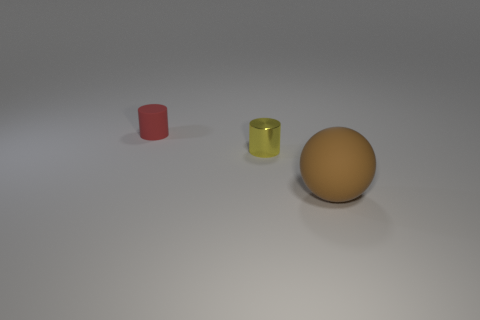What number of brown objects are there?
Ensure brevity in your answer.  1. How many things are small cylinders that are behind the small yellow shiny cylinder or brown spheres?
Your answer should be compact. 2. Does the small thing that is in front of the red cylinder have the same color as the matte ball?
Give a very brief answer. No. How many other objects are the same color as the large ball?
Keep it short and to the point. 0. What number of tiny objects are either purple spheres or metal things?
Make the answer very short. 1. Are there more large brown objects than large red metal spheres?
Your answer should be compact. Yes. Does the yellow object have the same material as the big brown thing?
Provide a succinct answer. No. Is there any other thing that is the same material as the tiny yellow thing?
Your response must be concise. No. Are there more red matte objects on the right side of the big rubber thing than tiny shiny cylinders?
Offer a very short reply. No. Does the metal thing have the same color as the sphere?
Provide a succinct answer. No. 